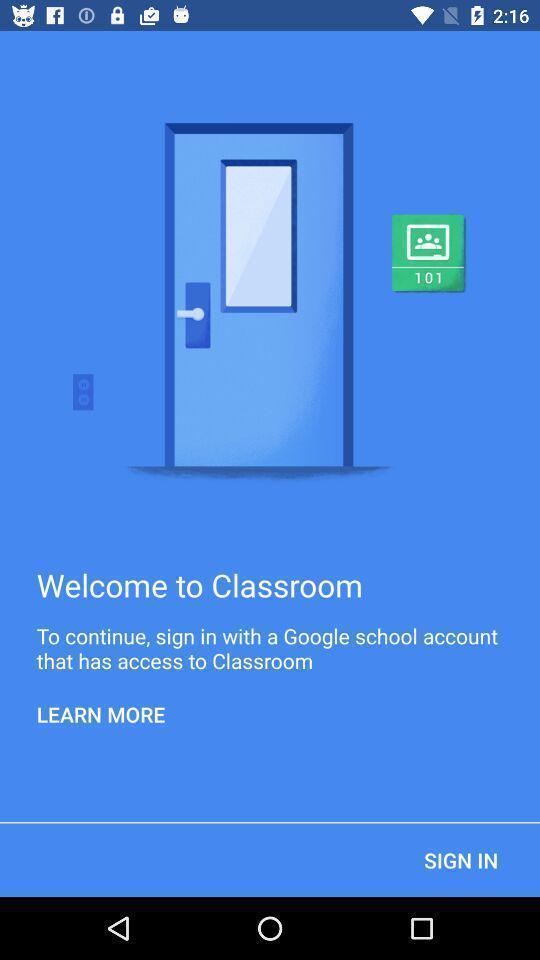Tell me what you see in this picture. Welcome page to the application with sign in option. 